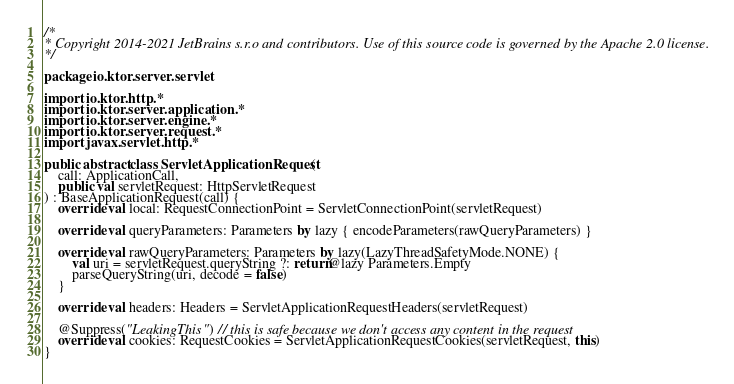<code> <loc_0><loc_0><loc_500><loc_500><_Kotlin_>/*
* Copyright 2014-2021 JetBrains s.r.o and contributors. Use of this source code is governed by the Apache 2.0 license.
*/

package io.ktor.server.servlet

import io.ktor.http.*
import io.ktor.server.application.*
import io.ktor.server.engine.*
import io.ktor.server.request.*
import javax.servlet.http.*

public abstract class ServletApplicationRequest(
    call: ApplicationCall,
    public val servletRequest: HttpServletRequest
) : BaseApplicationRequest(call) {
    override val local: RequestConnectionPoint = ServletConnectionPoint(servletRequest)

    override val queryParameters: Parameters by lazy { encodeParameters(rawQueryParameters) }

    override val rawQueryParameters: Parameters by lazy(LazyThreadSafetyMode.NONE) {
        val uri = servletRequest.queryString ?: return@lazy Parameters.Empty
        parseQueryString(uri, decode = false)
    }

    override val headers: Headers = ServletApplicationRequestHeaders(servletRequest)

    @Suppress("LeakingThis") // this is safe because we don't access any content in the request
    override val cookies: RequestCookies = ServletApplicationRequestCookies(servletRequest, this)
}
</code> 